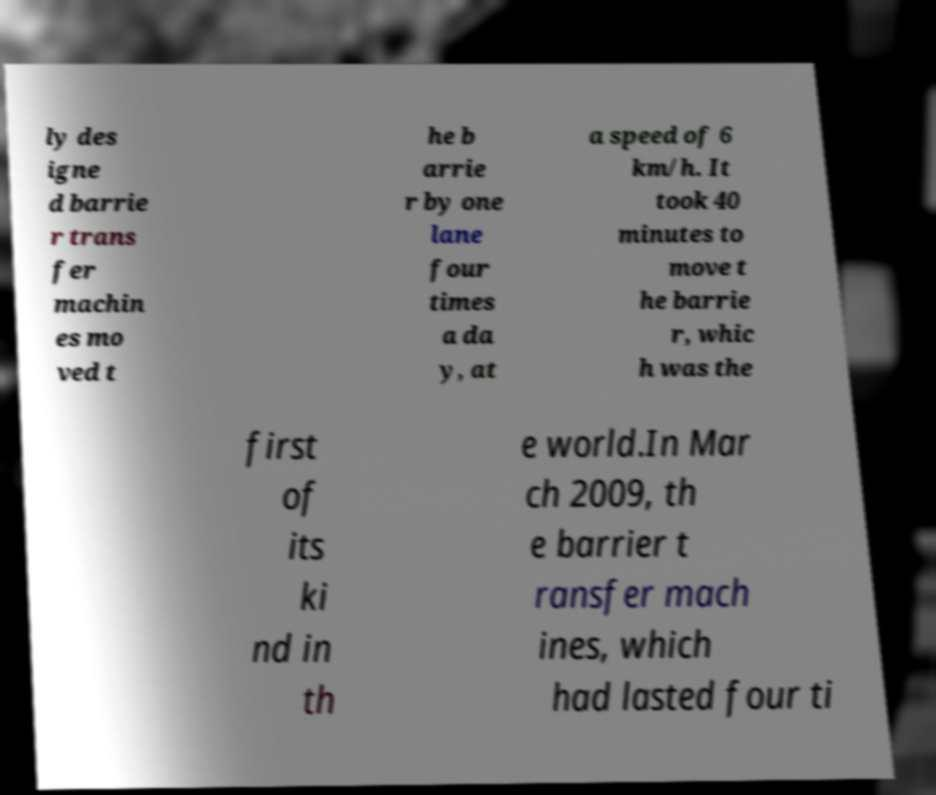For documentation purposes, I need the text within this image transcribed. Could you provide that? ly des igne d barrie r trans fer machin es mo ved t he b arrie r by one lane four times a da y, at a speed of 6 km/h. It took 40 minutes to move t he barrie r, whic h was the first of its ki nd in th e world.In Mar ch 2009, th e barrier t ransfer mach ines, which had lasted four ti 